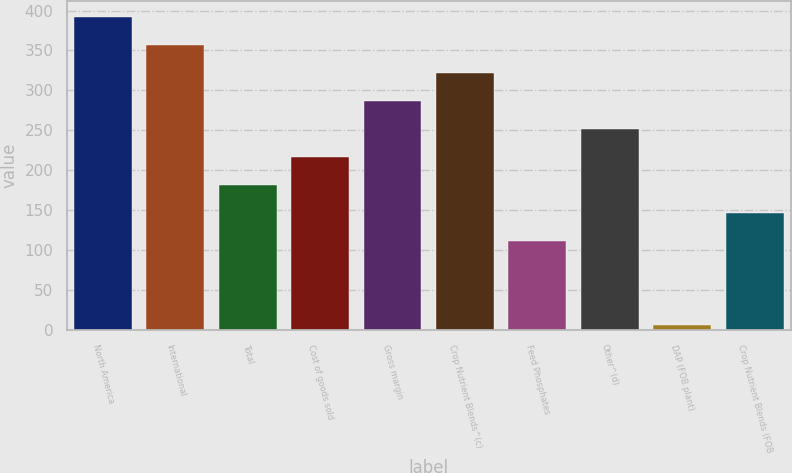Convert chart. <chart><loc_0><loc_0><loc_500><loc_500><bar_chart><fcel>North America<fcel>International<fcel>Total<fcel>Cost of goods sold<fcel>Gross margin<fcel>Crop Nutrient Blends^(c)<fcel>Feed Phosphates<fcel>Other^(d)<fcel>DAP (FOB plant)<fcel>Crop Nutrient Blends (FOB<nl><fcel>392.1<fcel>357<fcel>181.5<fcel>216.6<fcel>286.8<fcel>321.9<fcel>111.3<fcel>251.7<fcel>6<fcel>146.4<nl></chart> 